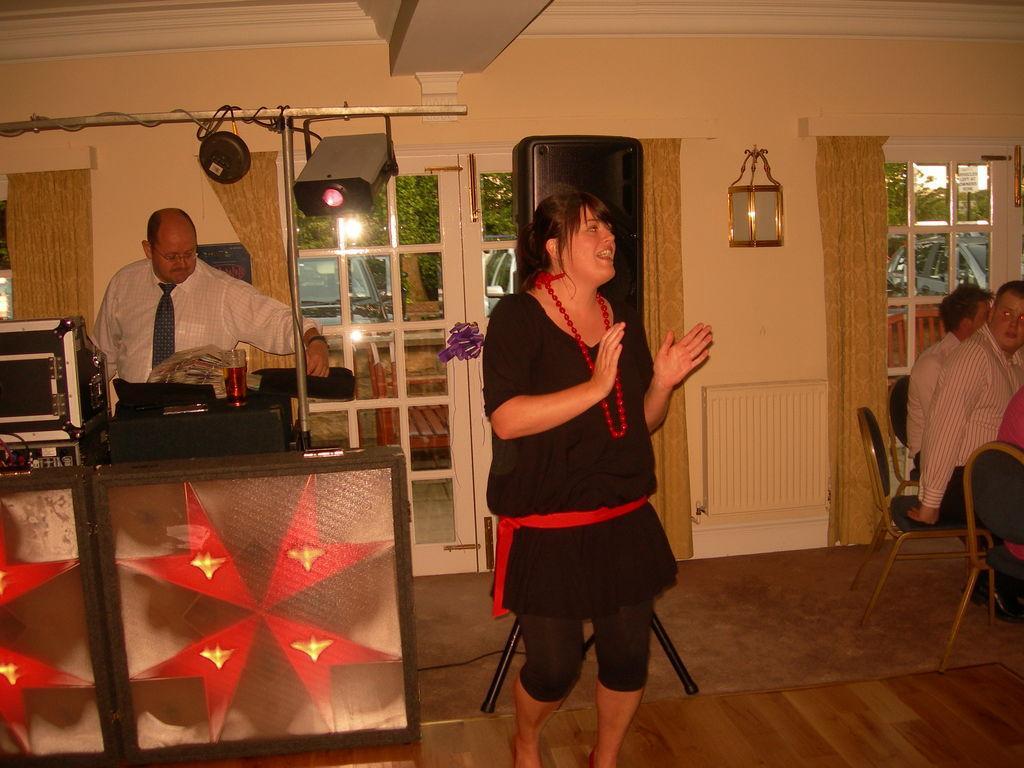Could you give a brief overview of what you see in this image? The picture is taken in a house. In the center of the picture there is a woman. On the left there are music control systems, table, glass, stand, person, curtains, light and other objects. On the right there are people, chairs, curtain, window and a lamp. In the background there are window and door, outside the door there are cars and trees. 